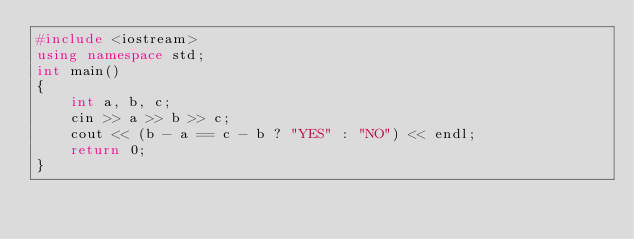<code> <loc_0><loc_0><loc_500><loc_500><_C++_>#include <iostream>
using namespace std;
int main()
{
    int a, b, c;
    cin >> a >> b >> c;
    cout << (b - a == c - b ? "YES" : "NO") << endl;
    return 0;
}</code> 